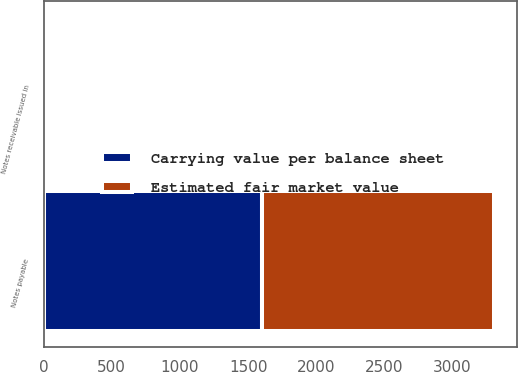Convert chart. <chart><loc_0><loc_0><loc_500><loc_500><stacked_bar_chart><ecel><fcel>Notes receivable issued in<fcel>Notes payable<nl><fcel>Carrying value per balance sheet<fcel>22.1<fcel>1600<nl><fcel>Estimated fair market value<fcel>23.2<fcel>1707.1<nl></chart> 